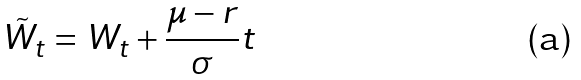Convert formula to latex. <formula><loc_0><loc_0><loc_500><loc_500>\tilde { W } _ { t } = W _ { t } + \frac { \mu - r } { \sigma } t</formula> 